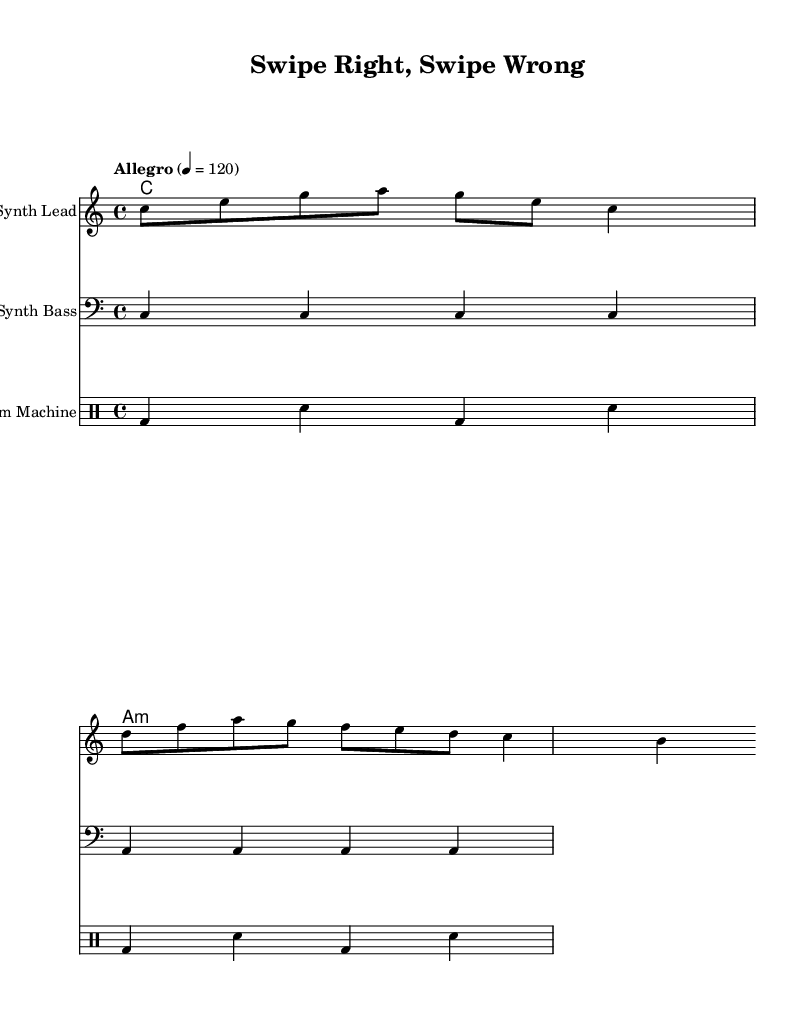What is the key signature of this music? The key signature is indicated at the beginning of the staff where there are no sharps or flats, which signifies it's in C major.
Answer: C major What is the time signature of the piece? The time signature is shown near the beginning of the sheet music, where it indicates the number of beats per measure and the note value that receives one beat; here, it is 4/4.
Answer: 4/4 What is the tempo marking of the piece? The tempo marking is provided right after the time signature, indicating how fast the piece should be played; it states "Allegro" with a metronome marking of 120 beats per minute.
Answer: Allegro How many measures are in the melody? By counting the vertical lines that indicate the end of each measure in the melody section, we find there are a total of 2 measures present.
Answer: 2 What instrument is indicated for the melody? The name of the instrument is stated at the beginning of the staff where the melody is written, and it is specified as "Synth Lead."
Answer: Synth Lead What is the characteristic rhythm pattern in the drums? The drum pattern shows a repeating four-note sequence of bass drum and snare drum; the consistent use of bass drum and snare creates a signature electronic rhythm suitable for synth-pop.
Answer: Bass and snare How do the lyrics relate to the theme of online dating? The lyrics describe experiences of swiping left and right, which metaphorically represent the online dating process, capturing the essence of modern dating mishaps in a playful manner.
Answer: Online dating 